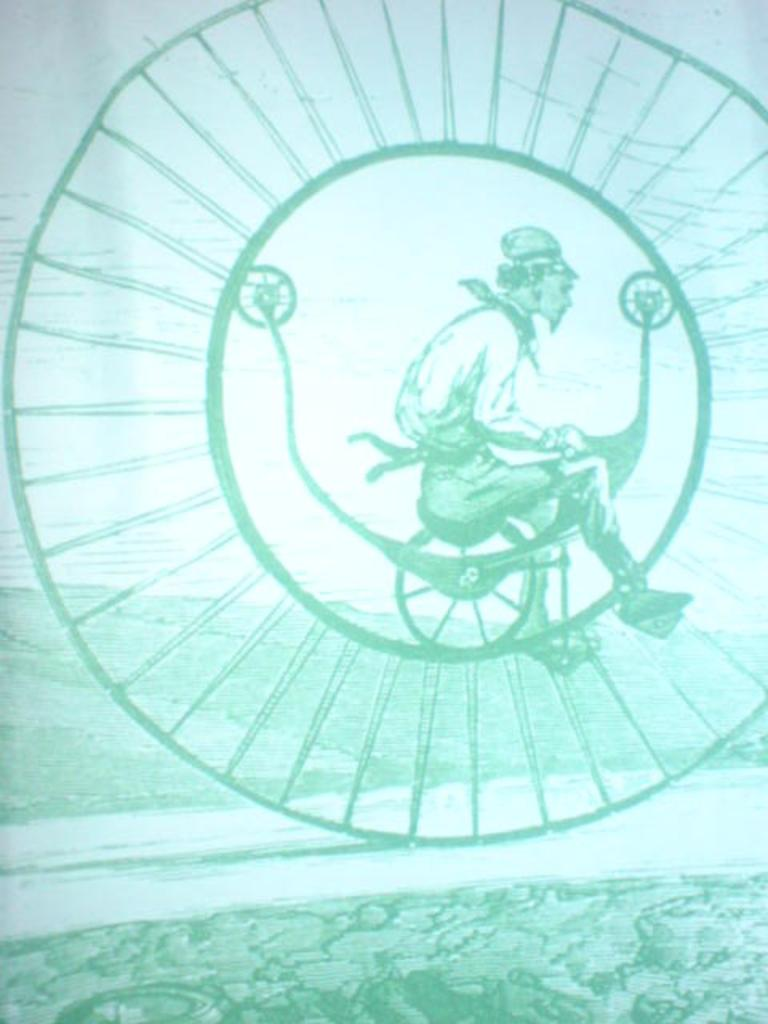Who or what is the main subject in the image? There is a person in the image. What is the person doing in the image? The person is riding a bicycle. What type of goat can be seen in the library talking to the person in the image? There is no goat or library present in the image; it features a person riding a bicycle. 